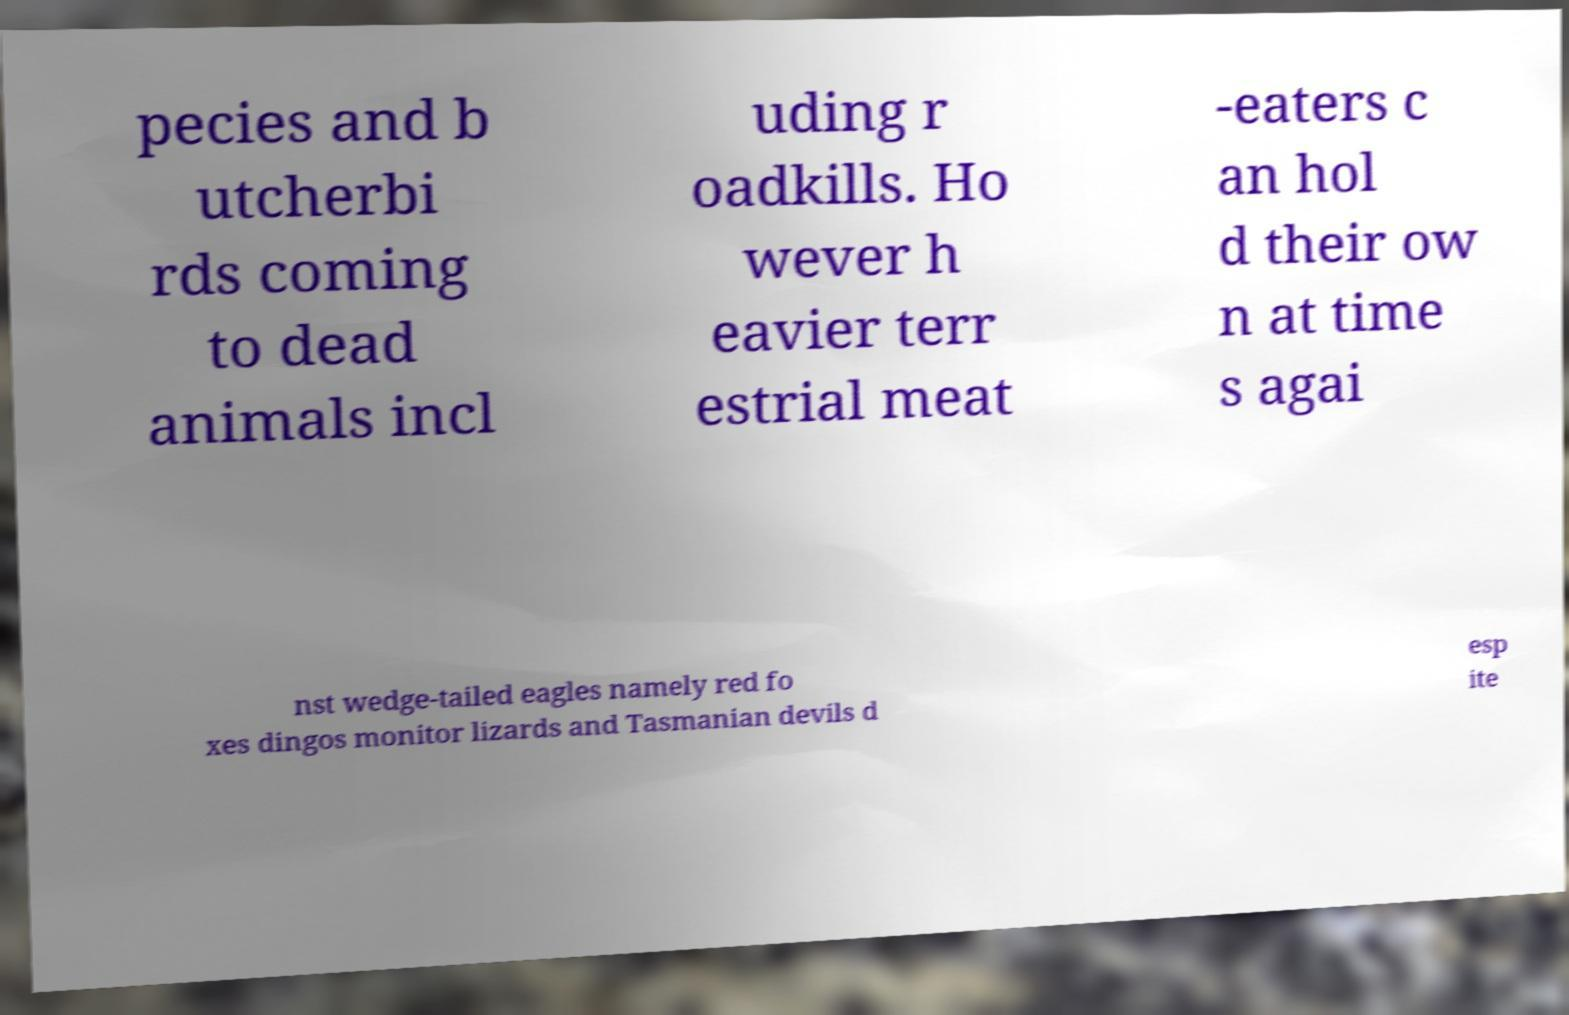For documentation purposes, I need the text within this image transcribed. Could you provide that? pecies and b utcherbi rds coming to dead animals incl uding r oadkills. Ho wever h eavier terr estrial meat -eaters c an hol d their ow n at time s agai nst wedge-tailed eagles namely red fo xes dingos monitor lizards and Tasmanian devils d esp ite 